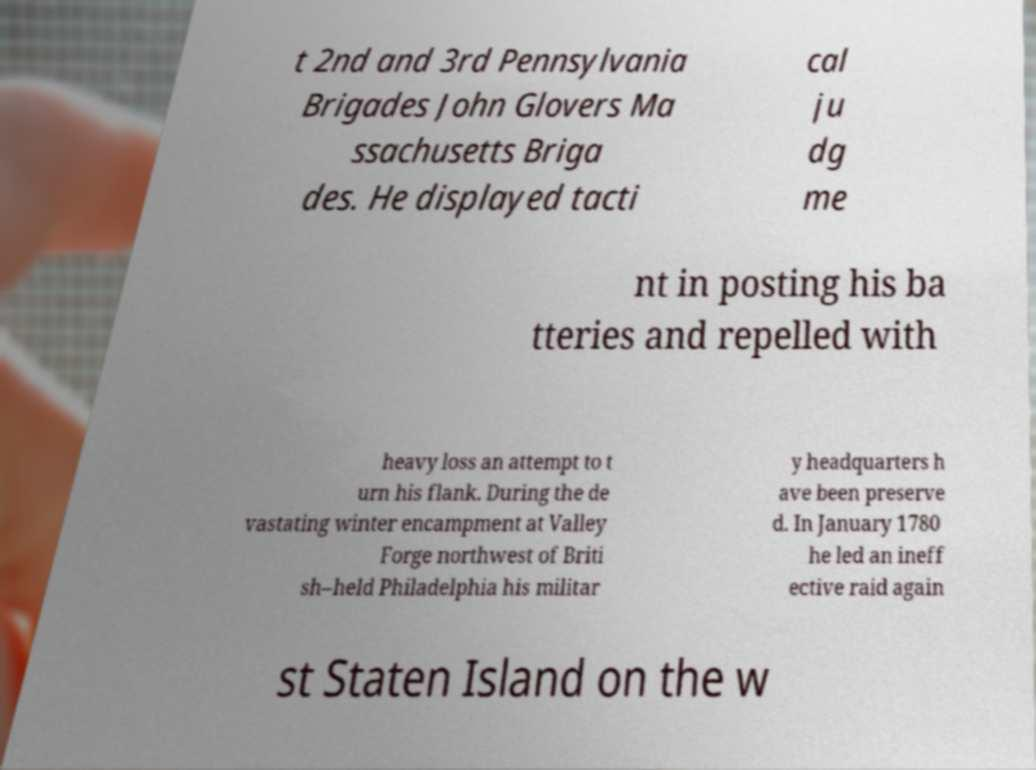Could you assist in decoding the text presented in this image and type it out clearly? t 2nd and 3rd Pennsylvania Brigades John Glovers Ma ssachusetts Briga des. He displayed tacti cal ju dg me nt in posting his ba tteries and repelled with heavy loss an attempt to t urn his flank. During the de vastating winter encampment at Valley Forge northwest of Briti sh–held Philadelphia his militar y headquarters h ave been preserve d. In January 1780 he led an ineff ective raid again st Staten Island on the w 